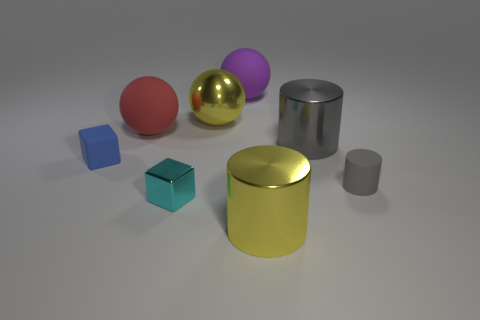What time of day does the lighting in the scene suggest? The lighting in the scene doesn't indicate a specific time of day as it seems to be artificial, likely from a studio setup. There's soft, diffused light coming from above, creating gentle shadows, consistent with an indoor photo shoot or a computer-generated image with controlled lighting conditions. 